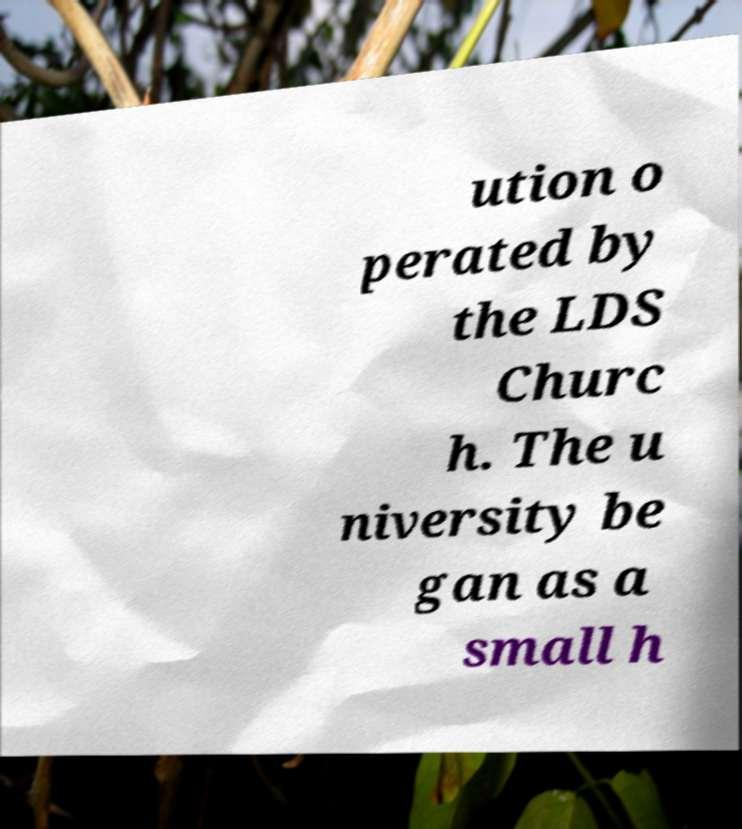What messages or text are displayed in this image? I need them in a readable, typed format. ution o perated by the LDS Churc h. The u niversity be gan as a small h 